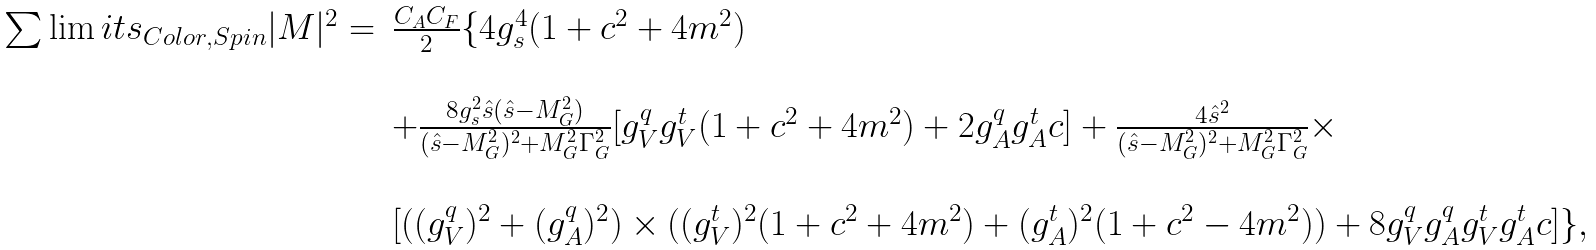<formula> <loc_0><loc_0><loc_500><loc_500>\begin{array} { r l } \sum \lim i t s _ { C o l o r , S p i n } | M | ^ { 2 } = & \frac { C _ { A } C _ { F } } { 2 } \{ 4 g _ { s } ^ { 4 } ( 1 + c ^ { 2 } + 4 m ^ { 2 } ) \\ \\ & + \frac { 8 g _ { s } ^ { 2 } \hat { s } ( \hat { s } - M _ { G } ^ { 2 } ) } { ( \hat { s } - M _ { G } ^ { 2 } ) ^ { 2 } + M _ { G } ^ { 2 } \Gamma _ { G } ^ { 2 } } [ g _ { V } ^ { q } g _ { V } ^ { t } ( 1 + c ^ { 2 } + 4 m ^ { 2 } ) + 2 g _ { A } ^ { q } g _ { A } ^ { t } c ] + \frac { 4 \hat { s } ^ { 2 } } { ( \hat { s } - M _ { G } ^ { 2 } ) ^ { 2 } + M _ { G } ^ { 2 } \Gamma _ { G } ^ { 2 } } \times \\ \\ & [ ( ( g _ { V } ^ { q } ) ^ { 2 } + ( g _ { A } ^ { q } ) ^ { 2 } ) \times ( ( g _ { V } ^ { t } ) ^ { 2 } ( 1 + c ^ { 2 } + 4 m ^ { 2 } ) + ( g _ { A } ^ { t } ) ^ { 2 } ( 1 + c ^ { 2 } - 4 m ^ { 2 } ) ) + 8 g _ { V } ^ { q } g _ { A } ^ { q } g _ { V } ^ { t } g _ { A } ^ { t } c ] \} , \end{array}</formula> 